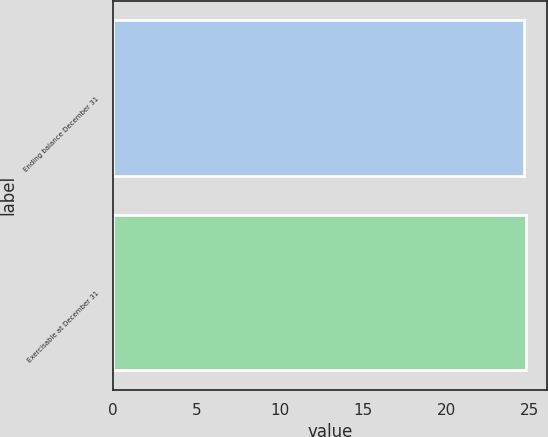Convert chart to OTSL. <chart><loc_0><loc_0><loc_500><loc_500><bar_chart><fcel>Ending balance December 31<fcel>Exercisable at December 31<nl><fcel>24.66<fcel>24.76<nl></chart> 